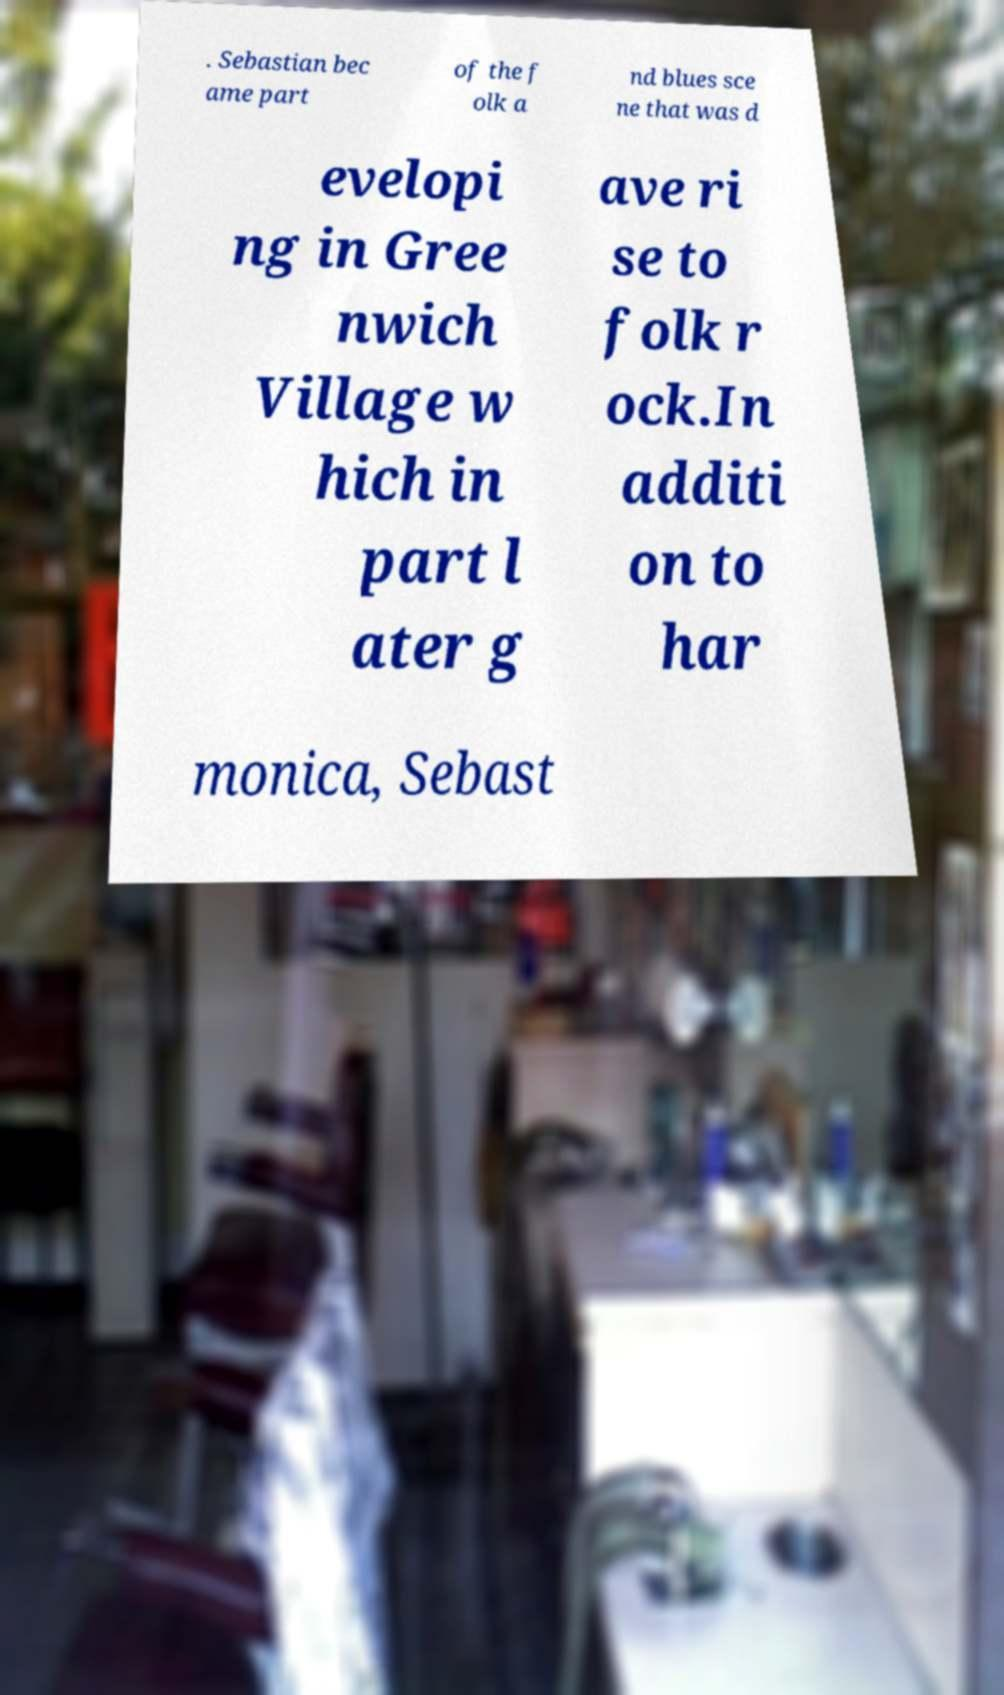Please read and relay the text visible in this image. What does it say? . Sebastian bec ame part of the f olk a nd blues sce ne that was d evelopi ng in Gree nwich Village w hich in part l ater g ave ri se to folk r ock.In additi on to har monica, Sebast 